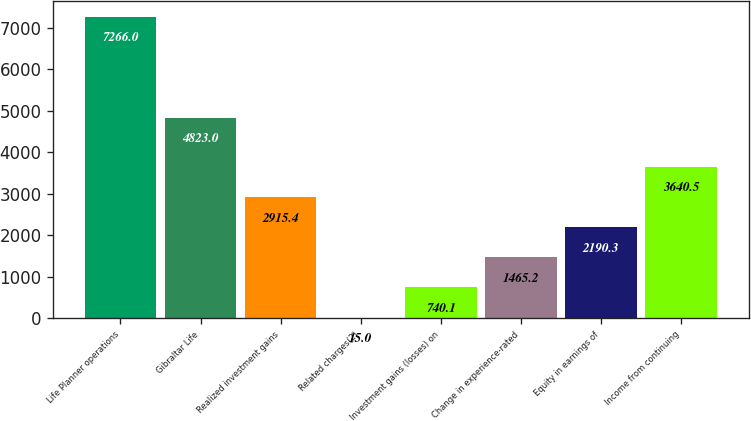Convert chart. <chart><loc_0><loc_0><loc_500><loc_500><bar_chart><fcel>Life Planner operations<fcel>Gibraltar Life<fcel>Realized investment gains<fcel>Related charges(2)<fcel>Investment gains (losses) on<fcel>Change in experience-rated<fcel>Equity in earnings of<fcel>Income from continuing<nl><fcel>7266<fcel>4823<fcel>2915.4<fcel>15<fcel>740.1<fcel>1465.2<fcel>2190.3<fcel>3640.5<nl></chart> 